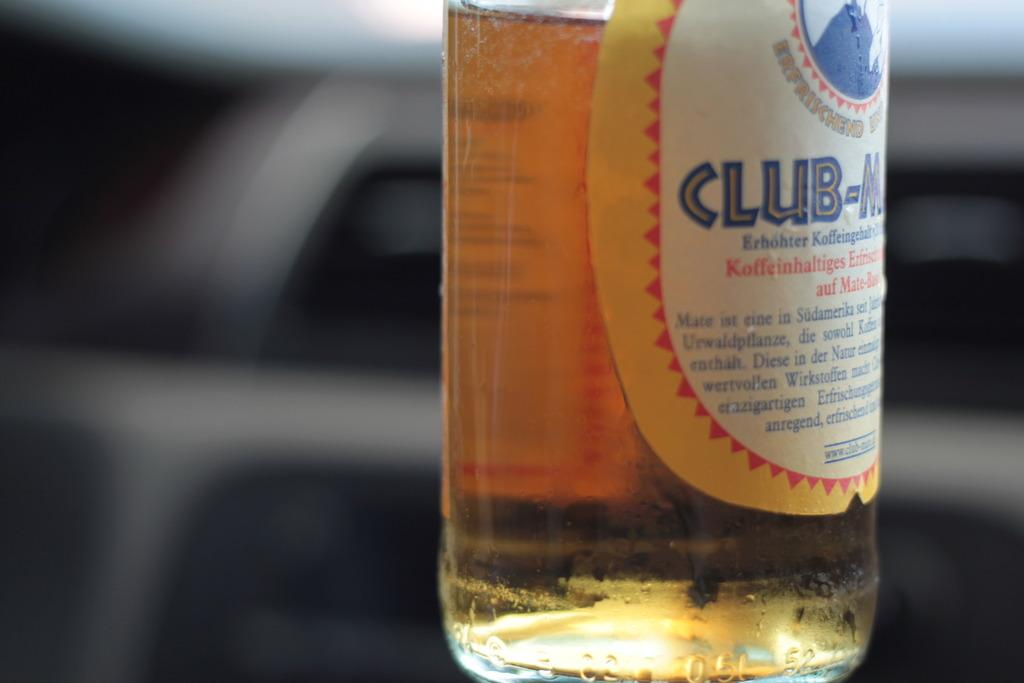<image>
Render a clear and concise summary of the photo. a Club-Mate beer bottle with half of the bottle full 